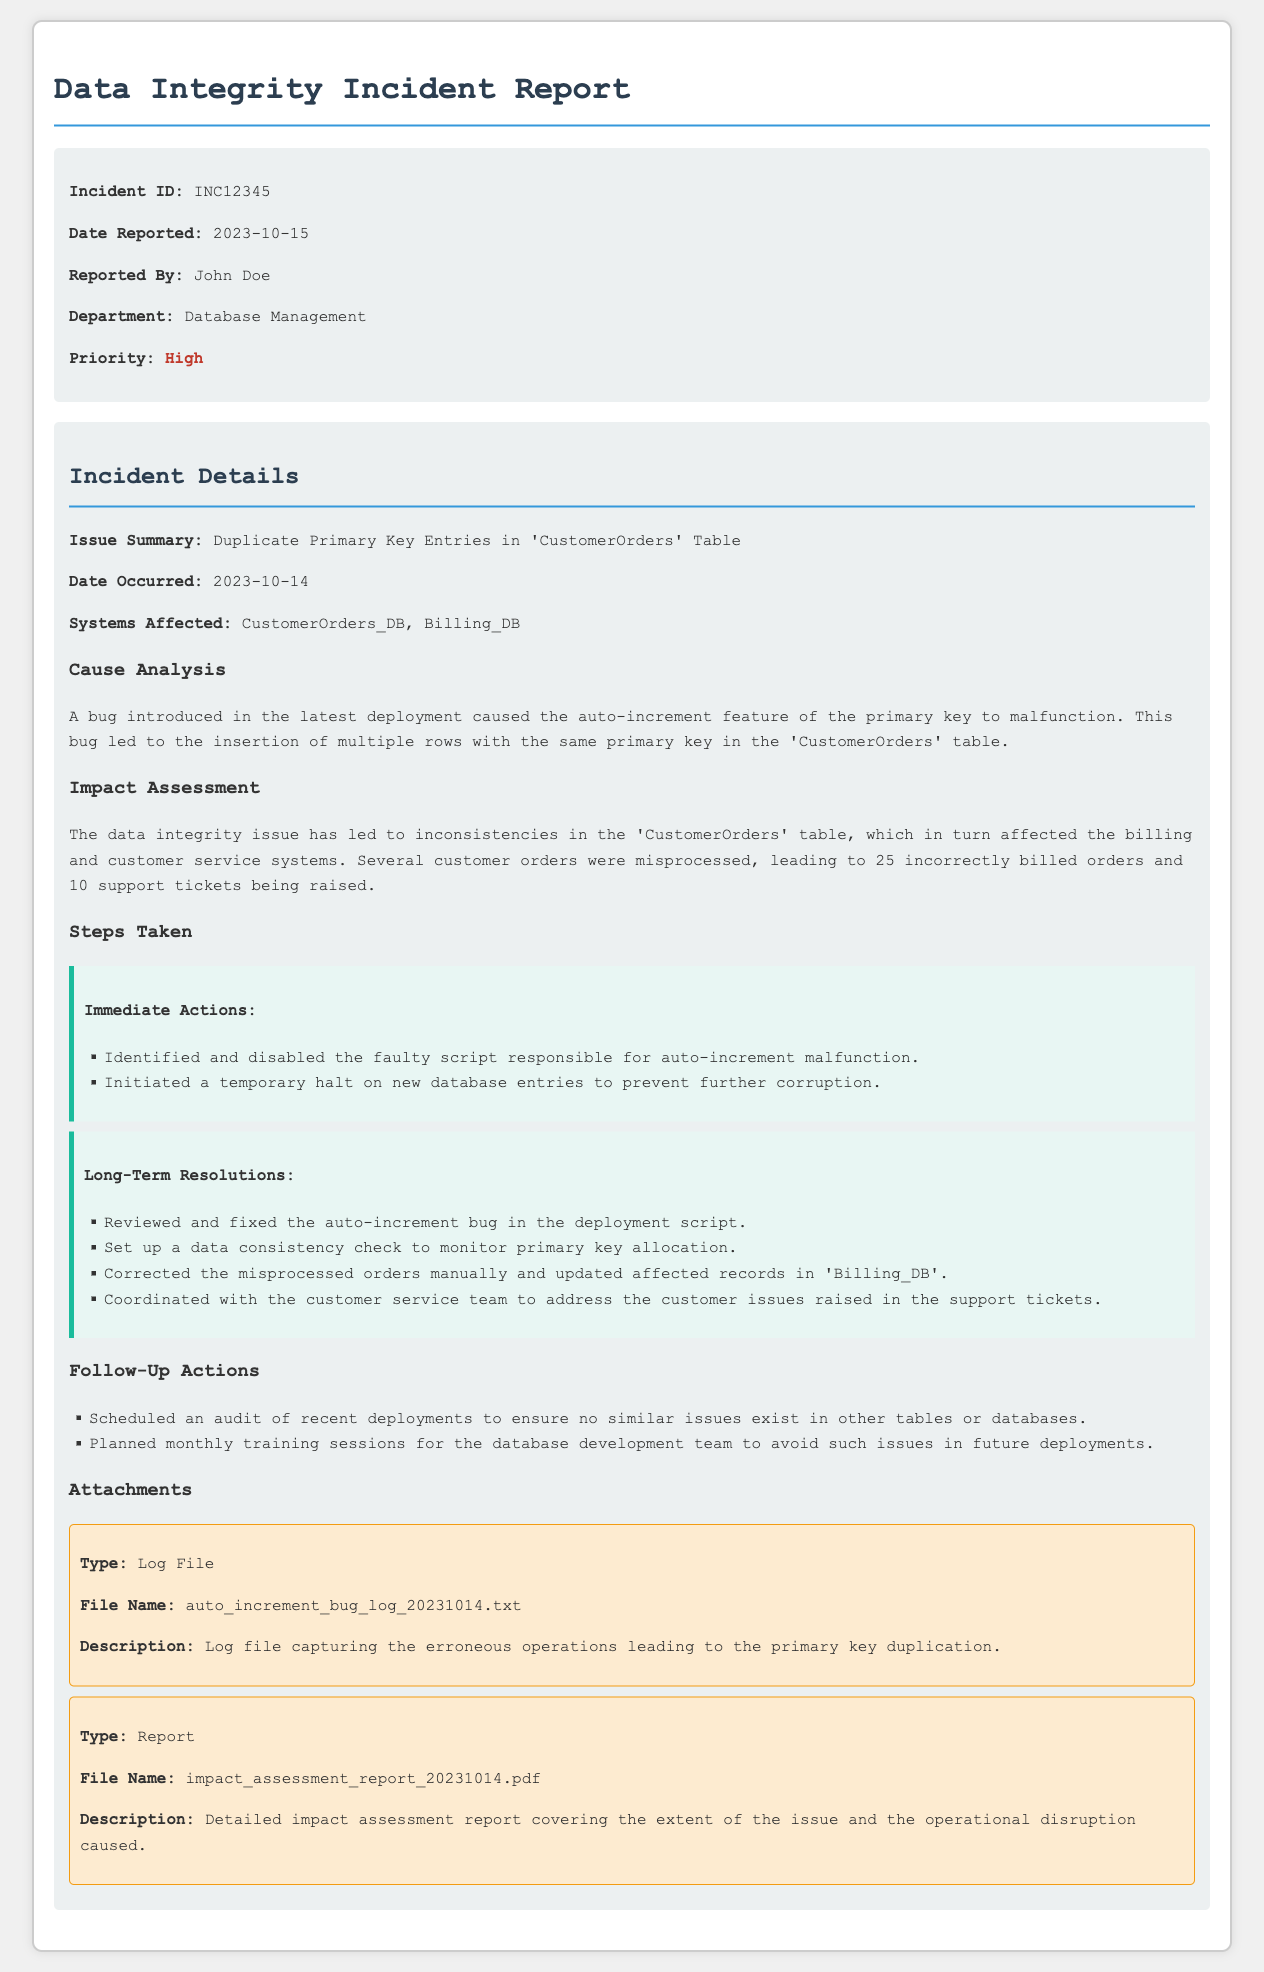What is the Incident ID? The Incident ID is listed in the details section of the document, which is INC12345.
Answer: INC12345 Who reported the incident? The report indicates that John Doe is the person who reported the incident.
Answer: John Doe What was the date the issue occurred? The date the issue occurred is mentioned in the incident details, which is 2023-10-14.
Answer: 2023-10-14 How many incorrectly billed orders were identified? The impact assessment section specifies that there were 25 incorrectly billed orders due to the data integrity issue.
Answer: 25 What feature malfunctioned leading to the issue? The document states that the malfunctioning feature was the auto-increment feature of the primary key.
Answer: Auto-increment feature What immediate action was taken first? The first immediate action taken was to identify and disable the faulty script responsible for the auto-increment malfunction.
Answer: Disable the faulty script What is the priority level of the incident? The document categorizes the priority of the incident as High.
Answer: High What type of file was attached for the log? The attachment describes the log file as "auto_increment_bug_log_20231014.txt."
Answer: Log File Which system was primarily affected by the incident? The systems affected is mentioned in the incident details, which includes CustomerOrders_DB.
Answer: CustomerOrders_DB 